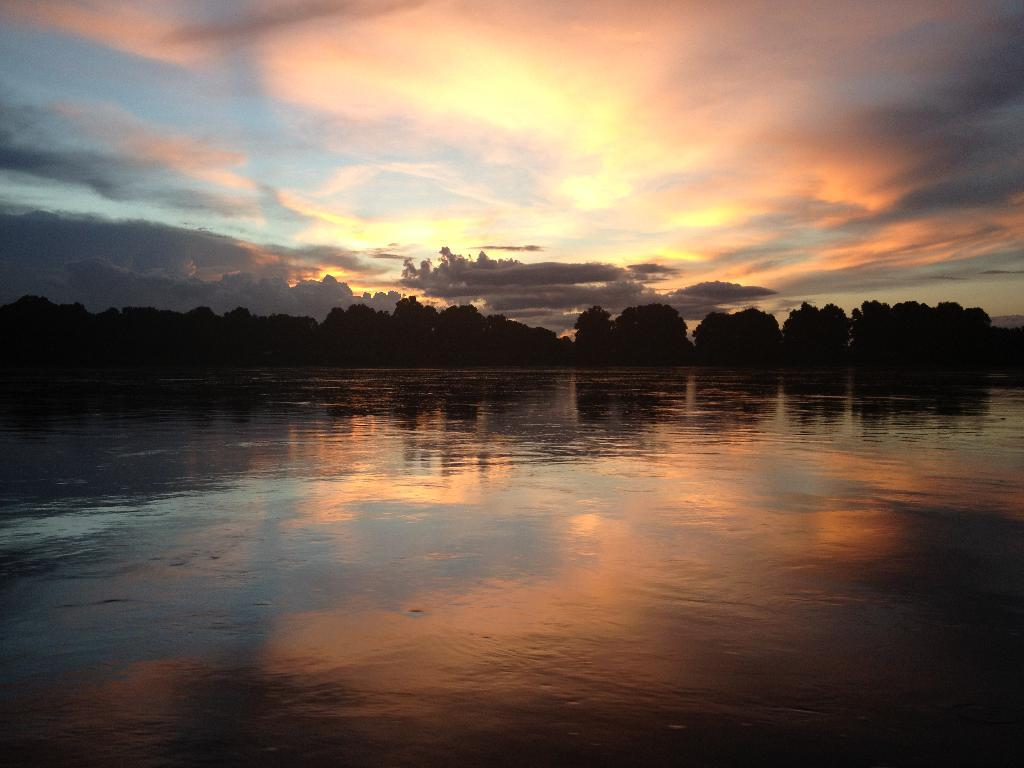What type of natural feature is present in the image? There is a group of trees in the image. What can be seen on the water surface in the image? There is a reflection of the sky on the water surface. How would you describe the sky in the image? The sky is slightly cloudy. What arithmetic problem can be solved using the branches of the trees in the image? There is no arithmetic problem present in the image, as it features a group of trees and a reflection of the sky on the water surface. Can you see any fairies flying around the trees in the image? There are no fairies present in the image; it only features a group of trees and a reflection of the sky on the water surface. 